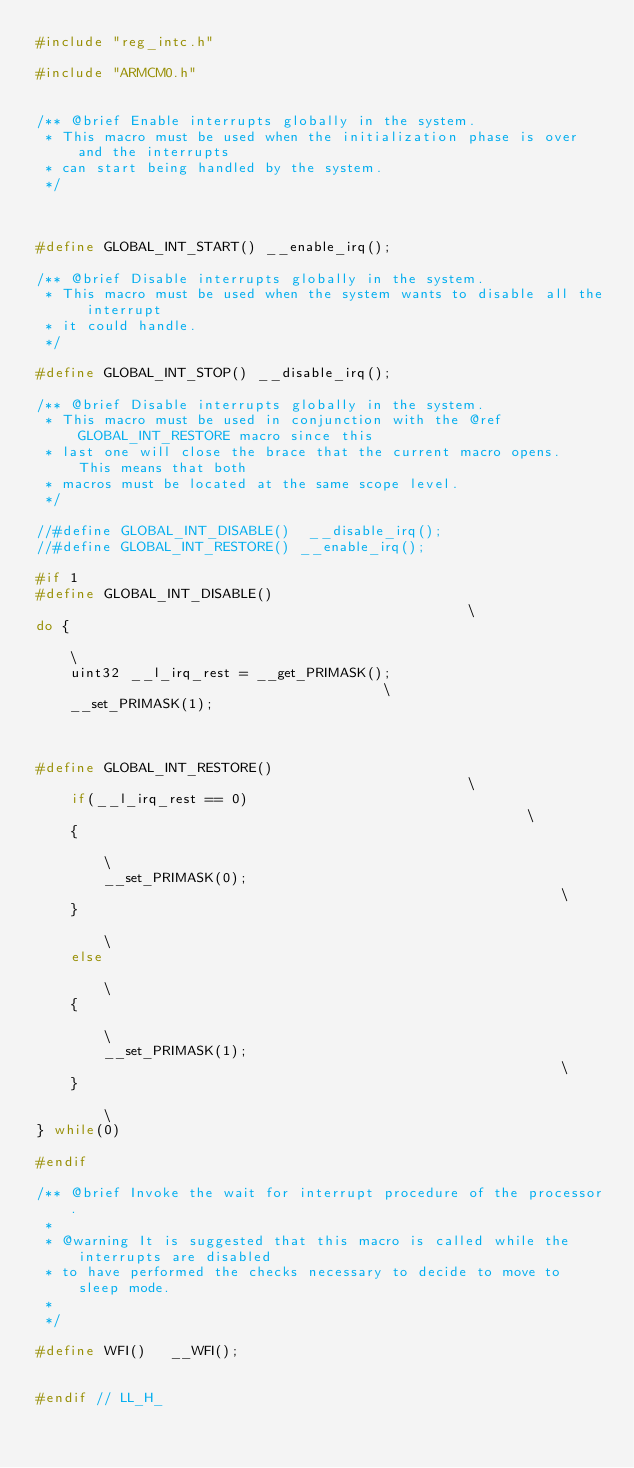Convert code to text. <code><loc_0><loc_0><loc_500><loc_500><_C_>#include "reg_intc.h"

#include "ARMCM0.h"


/** @brief Enable interrupts globally in the system.
 * This macro must be used when the initialization phase is over and the interrupts
 * can start being handled by the system.
 */ 



#define GLOBAL_INT_START() __enable_irq();                            

/** @brief Disable interrupts globally in the system.
 * This macro must be used when the system wants to disable all the interrupt
 * it could handle.
 */

#define GLOBAL_INT_STOP() __disable_irq();

/** @brief Disable interrupts globally in the system.
 * This macro must be used in conjunction with the @ref GLOBAL_INT_RESTORE macro since this
 * last one will close the brace that the current macro opens.  This means that both
 * macros must be located at the same scope level.
 */

//#define GLOBAL_INT_DISABLE()  __disable_irq();
//#define GLOBAL_INT_RESTORE() __enable_irq(); 

#if 1
#define GLOBAL_INT_DISABLE()                                                \
do {                                                                        \
    uint32 __l_irq_rest = __get_PRIMASK();                                  \
    __set_PRIMASK(1);                                                      
    


#define GLOBAL_INT_RESTORE()                                                \
    if(__l_irq_rest == 0)                                                   \
    {                                                                       \
        __set_PRIMASK(0);                                                   \
    }                                                                       \
    else                                                                    \
    {                                                                       \
        __set_PRIMASK(1);                                                   \
    }                                                                       \
} while(0)

#endif

/** @brief Invoke the wait for interrupt procedure of the processor.
 *
 * @warning It is suggested that this macro is called while the interrupts are disabled
 * to have performed the checks necessary to decide to move to sleep mode.
 *
 */

#define WFI()   __WFI();


#endif // LL_H_
</code> 